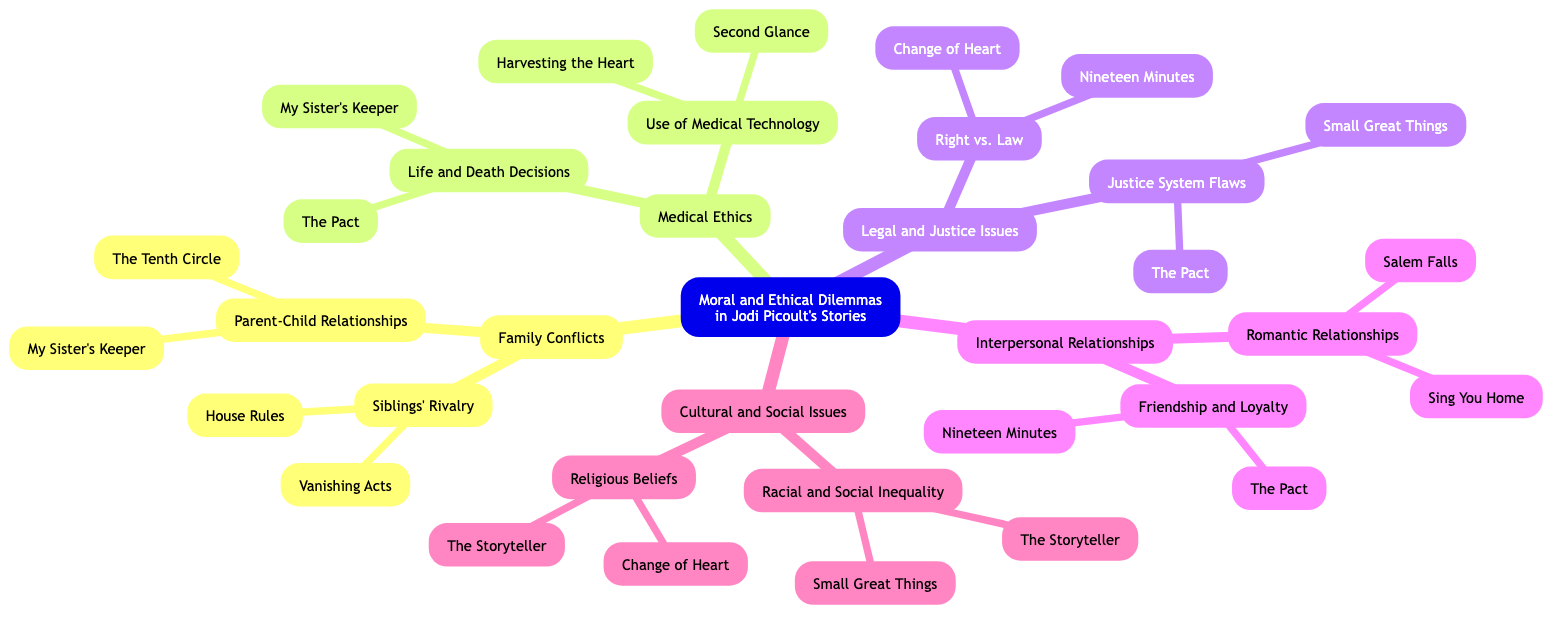What is the central topic of the mind map? The central topic is explicitly stated at the center of the diagram, which is "Moral and Ethical Dilemmas in Jodi Picoult's Stories."
Answer: Moral and Ethical Dilemmas in Jodi Picoult's Stories How many branches are there stemming from the central topic? Counting the branches that extend directly from the central topic, there are five branches listed: Family Conflicts, Medical Ethics, Legal and Justice Issues, Interpersonal Relationships, and Cultural and Social Issues.
Answer: 5 Which book is associated with both "Life and Death Decisions" and "Friendship and Loyalty"? Looking at the sub-branches, "My Sister's Keeper" is listed under "Life and Death Decisions" and "The Pact" is listed under "Friendship and Loyalty." Since both are connected through themes, we can see that "The Pact" is the common book for both branches.
Answer: The Pact What examples are provided under "Siblings' Rivalry"? The sub-branch "Siblings' Rivalry" lists two examples specifically, which are "Vanishing Acts" and "House Rules."
Answer: Vanishing Acts, House Rules Which ethical dilemma appears in "Nineteen Minutes"? The book "Nineteen Minutes" is categorized under both "Right vs. Law" and "Friendship and Loyalty," indicating it addresses dilemmas related to justice and interpersonal relationships.
Answer: Right vs. Law, Friendship and Loyalty What sub-branch appears under "Cultural and Social Issues"? The sub-branches under "Cultural and Social Issues" include "Racial and Social Inequality" and "Religious Beliefs."
Answer: Racial and Social Inequality, Religious Beliefs Which two books are listed under "Use of Medical Technology"? The examples listed under the sub-branch "Use of Medical Technology" are "Second Glance" and "Harvesting the Heart."
Answer: Second Glance, Harvesting the Heart What theme do "Small Great Things" and "The Storyteller" share? Both "Small Great Things" and "The Storyteller" are associated with the sub-branch "Racial and Social Inequality," indicating they share themes of social justice and cultural conflict.
Answer: Racial and Social Inequality Which branch has the most examples provided? By counting the examples under each branch, the "Medical Ethics" branch lists four examples (including sub-branches) which signifies it has the most examples overall.
Answer: Medical Ethics 